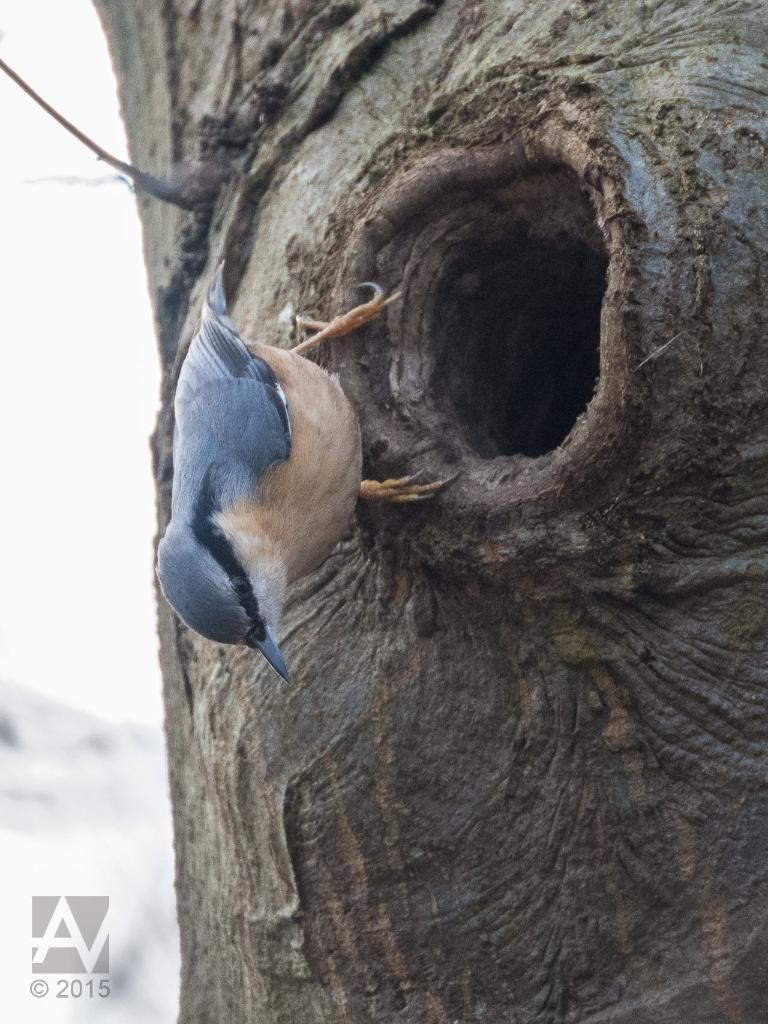What type of bird is on the trunk in the image? There is a woodpecker on the trunk in the image. What can be seen on the trunk besides the woodpecker? There is a hole on the trunk. Can you describe any additional features of the image? There is a watermark on the left side bottom of the image. What type of train can be seen passing by in the image? There is no train present in the image; it features a woodpecker on a trunk with a hole. What time of day is depicted in the image, considering the presence of a zephyr? The term "zephyr" refers to a gentle breeze, and there is no mention of a breeze or any specific time of day in the image. 